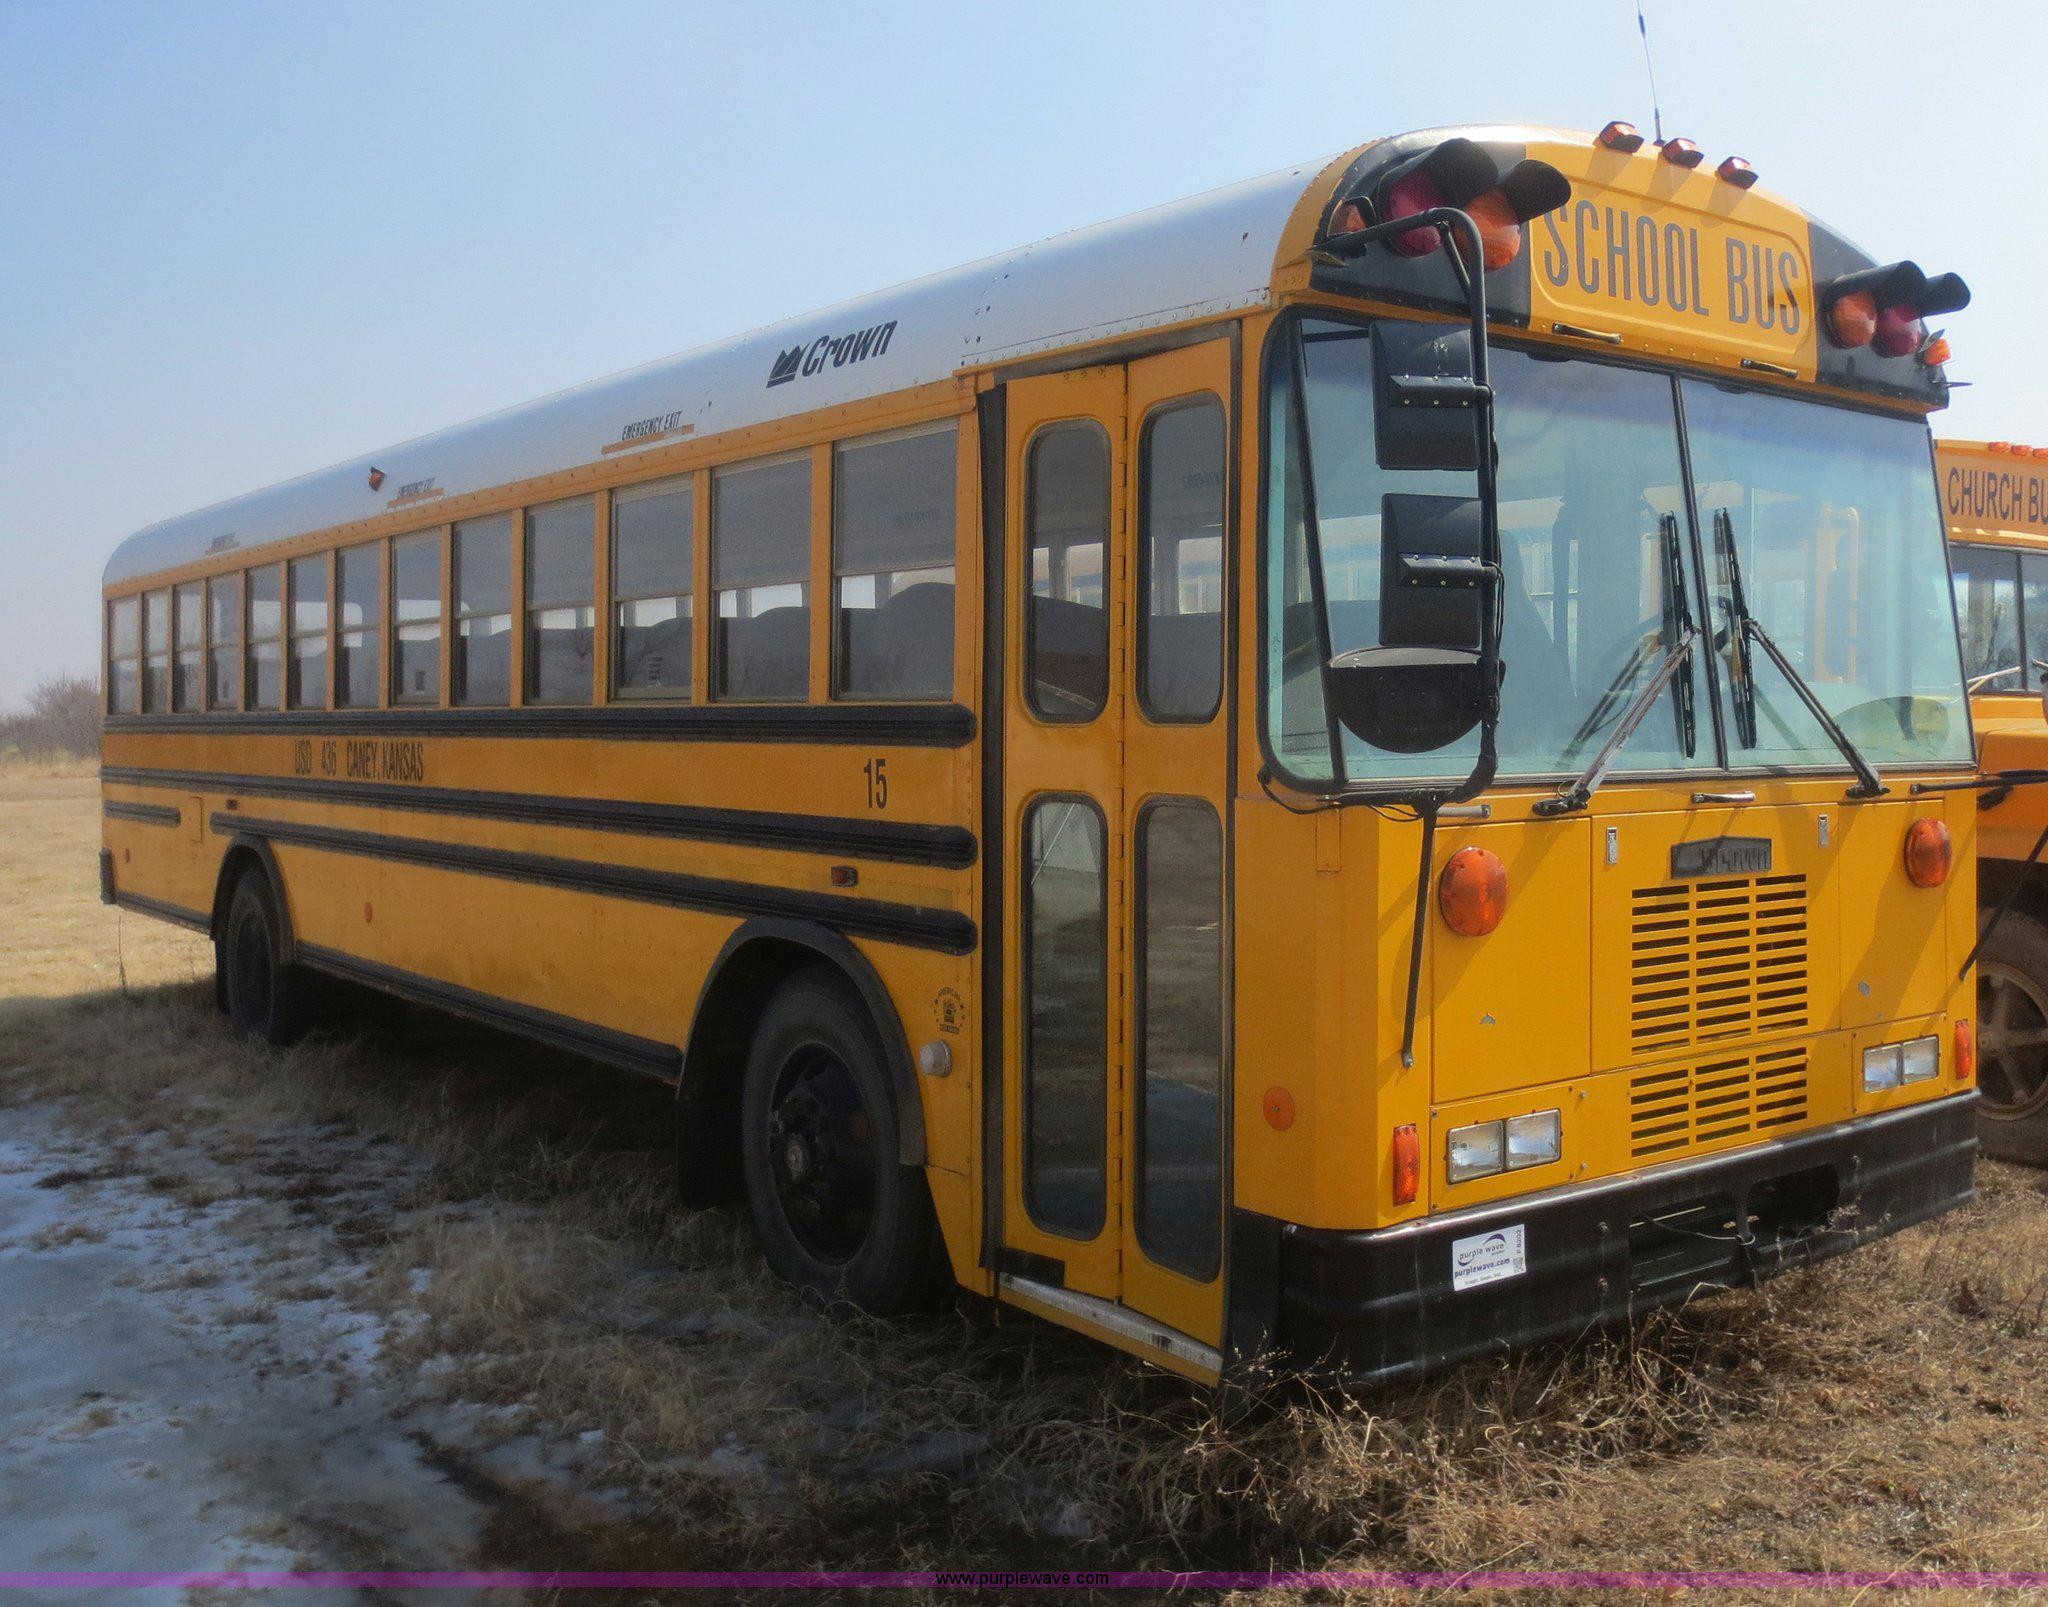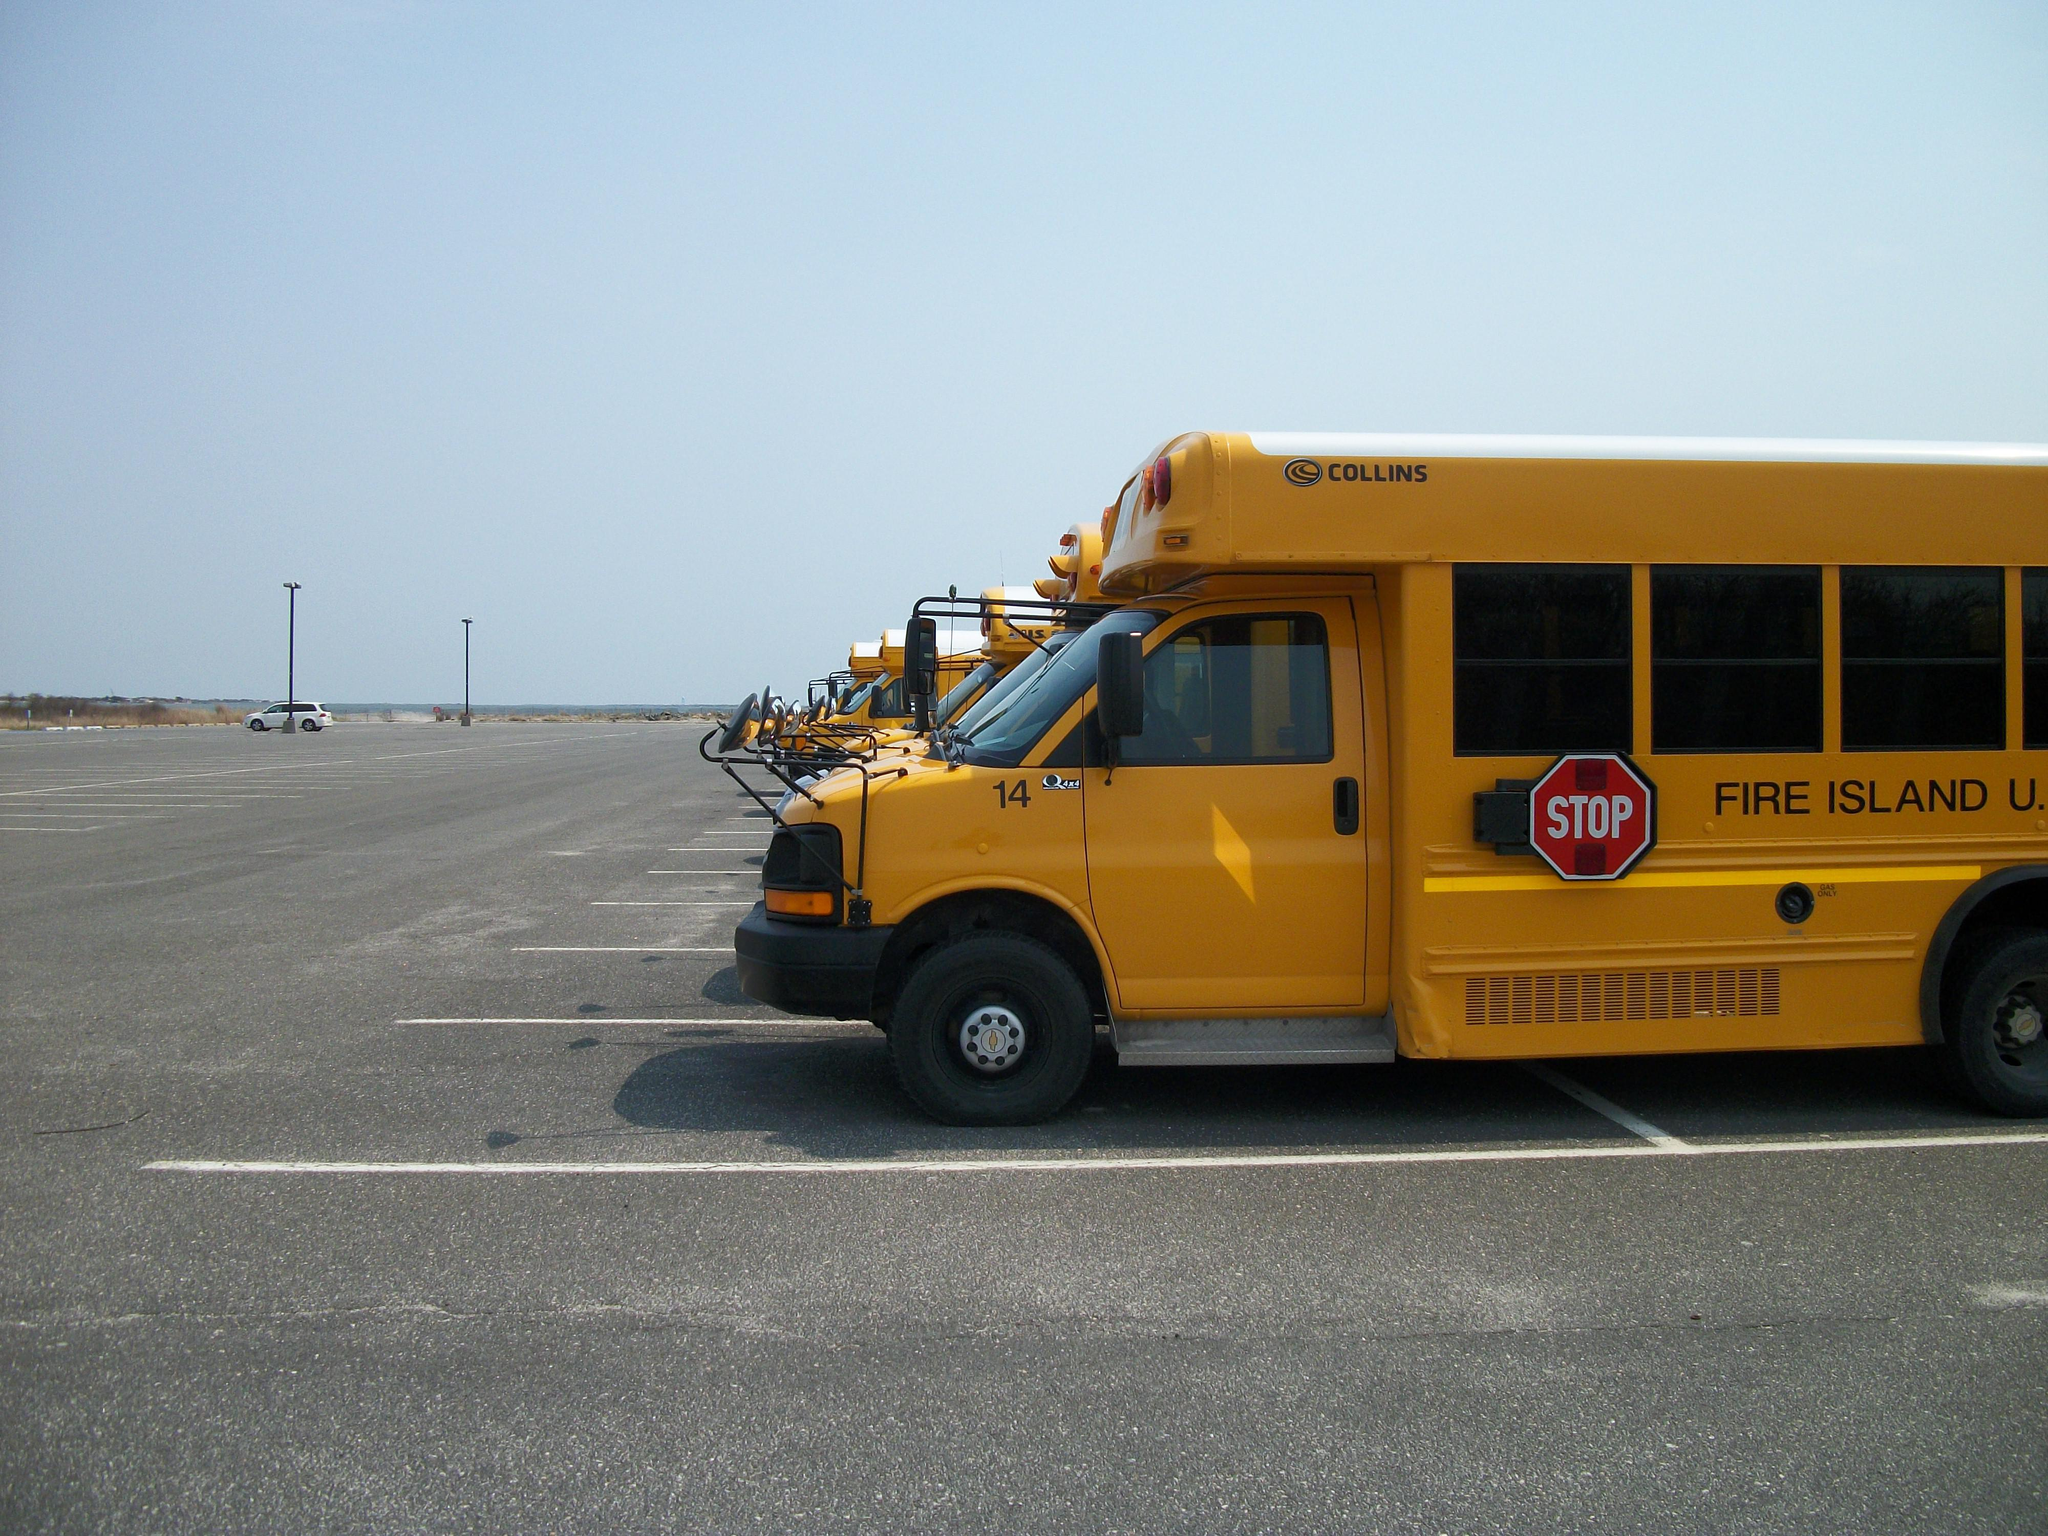The first image is the image on the left, the second image is the image on the right. For the images shown, is this caption "Exactly two buses are visible." true? Answer yes or no. No. The first image is the image on the left, the second image is the image on the right. For the images displayed, is the sentence "There are two school buses in total." factually correct? Answer yes or no. No. 